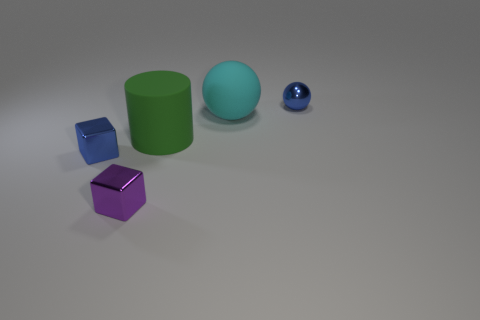Add 2 big red rubber things. How many objects exist? 7 Subtract all blocks. How many objects are left? 3 Add 2 blue metal spheres. How many blue metal spheres exist? 3 Subtract 0 brown balls. How many objects are left? 5 Subtract all large red spheres. Subtract all small blue shiny cubes. How many objects are left? 4 Add 1 small blue metallic balls. How many small blue metallic balls are left? 2 